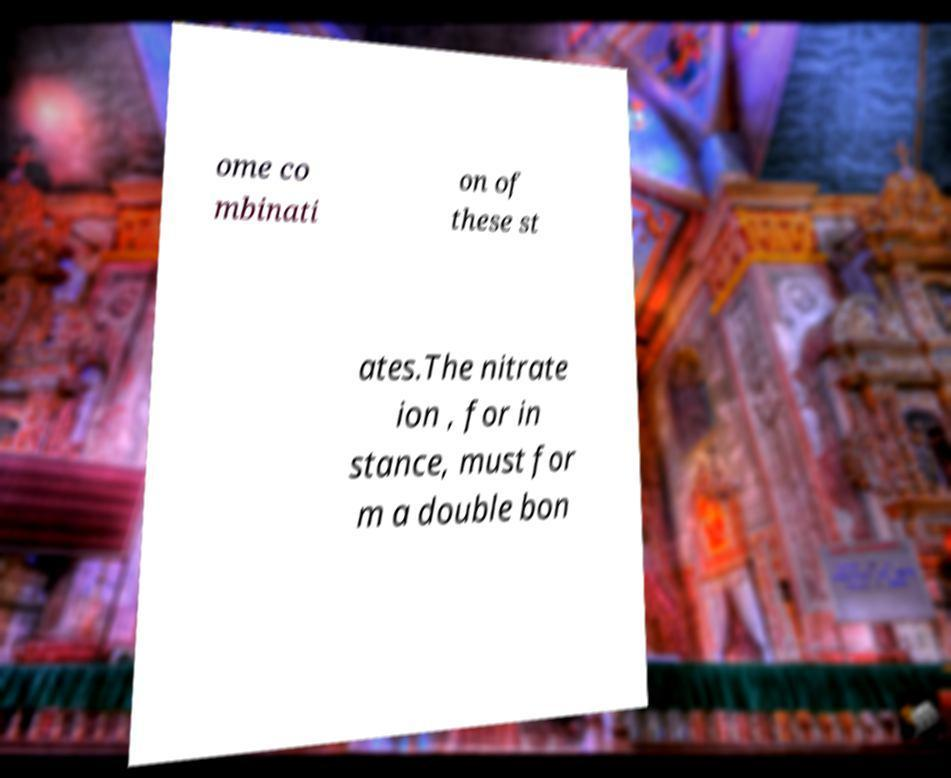I need the written content from this picture converted into text. Can you do that? ome co mbinati on of these st ates.The nitrate ion , for in stance, must for m a double bon 